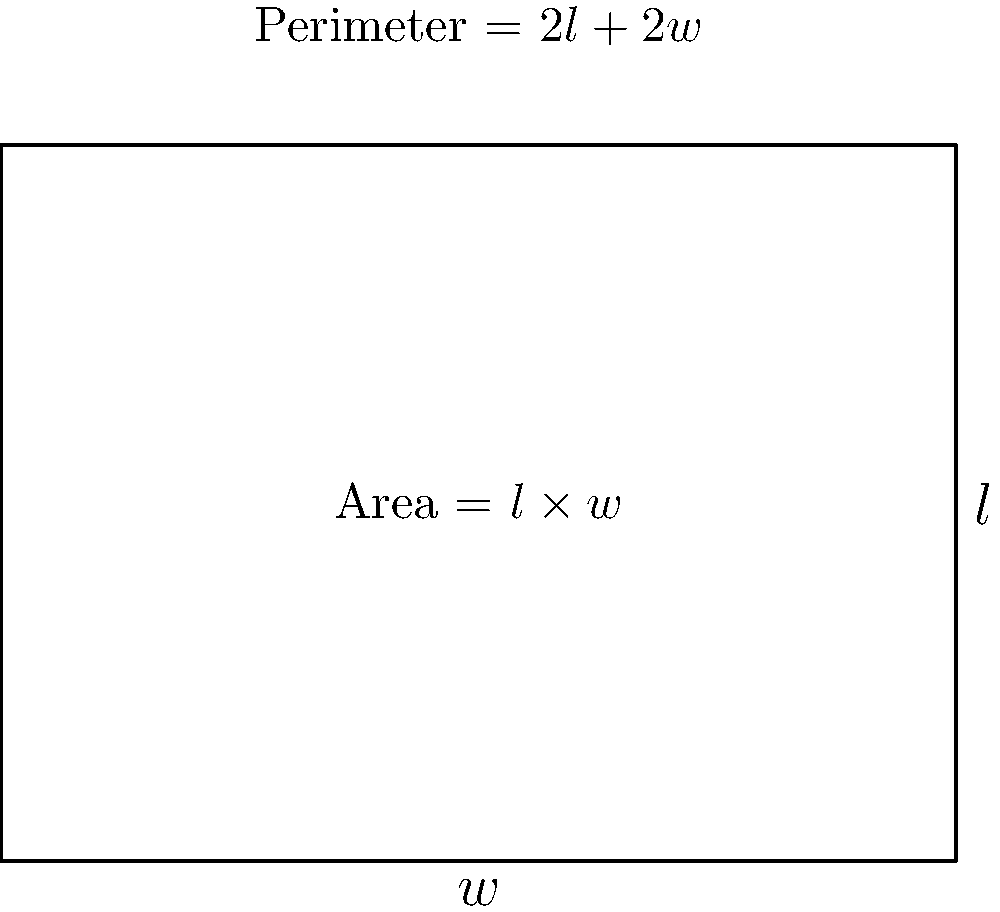As an education policy advisor evaluating digital solutions for improving educational outcomes, you're analyzing a proposal for optimizing classroom design. The proposal suggests using a digital tool to calculate the optimal dimensions of rectangular classrooms given a fixed perimeter. If a classroom has a fixed perimeter of 50 meters, what dimensions (length and width) would maximize the classroom area? How does this relate to the effectiveness of digital solutions in education? Let's approach this step-by-step:

1) Let $l$ be the length and $w$ be the width of the classroom.

2) Given the perimeter is 50 meters, we can write:
   $2l + 2w = 50$

3) Solving for $l$:
   $l = 25 - w$

4) The area $A$ of the classroom is given by:
   $A = lw = (25-w)w = 25w - w^2$

5) To find the maximum area, we need to find where $\frac{dA}{dw} = 0$:
   $\frac{dA}{dw} = 25 - 2w$

6) Setting this equal to zero:
   $25 - 2w = 0$
   $2w = 25$
   $w = 12.5$

7) Since $l = 25 - w$, we also have $l = 12.5$

8) To confirm this is a maximum, we can check that $\frac{d^2A}{dw^2} < 0$:
   $\frac{d^2A}{dw^2} = -2$, which is indeed negative.

This result shows that a square classroom (12.5m x 12.5m) maximizes the area.

Relating to digital solutions in education:
This example demonstrates how digital tools can quickly solve complex optimization problems, allowing for more efficient use of resources in education. Such tools can help in various aspects of educational planning, from classroom design to curriculum optimization, potentially leading to improved learning environments and outcomes.
Answer: Length = 12.5m, Width = 12.5m; Digital tools enable quick, precise optimization for educational resource allocation. 